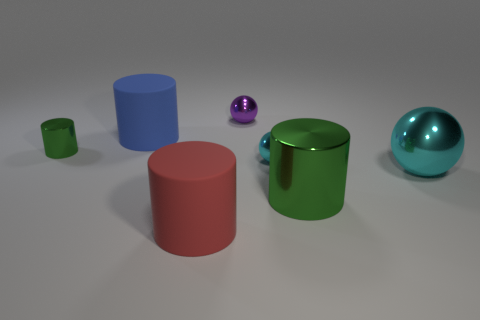Is there anything else that is the same shape as the large green metallic object?
Offer a very short reply. Yes. What is the green cylinder left of the big blue rubber object made of?
Ensure brevity in your answer.  Metal. What is the size of the red thing that is the same shape as the big blue matte thing?
Offer a terse response. Large. What number of large blue things are the same material as the big cyan sphere?
Provide a succinct answer. 0. What number of tiny metal objects are the same color as the tiny cylinder?
Make the answer very short. 0. What number of things are either small metal things that are behind the big blue rubber cylinder or metal things to the right of the large red cylinder?
Keep it short and to the point. 4. Is the number of shiny cylinders behind the large red cylinder less than the number of objects?
Give a very brief answer. Yes. Are there any other objects that have the same size as the blue matte thing?
Your response must be concise. Yes. What color is the large shiny cylinder?
Ensure brevity in your answer.  Green. Do the blue rubber object and the purple metallic thing have the same size?
Ensure brevity in your answer.  No. 